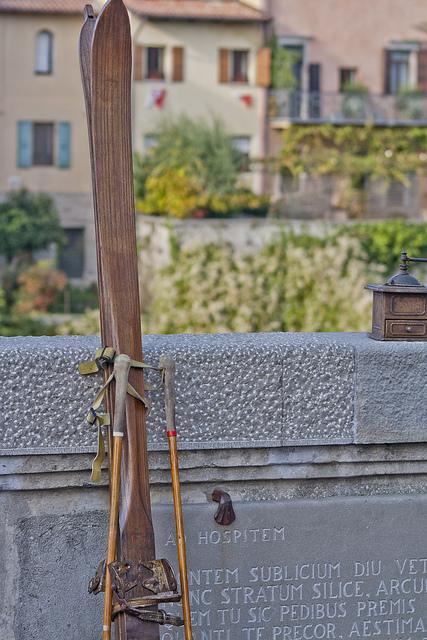What language is on the stone?
Quick response, please. Latin. Is there a balcony in the background?
Short answer required. Yes. What is that object behind the skis?
Concise answer only. Wall. Does the building in the background have shutters?
Give a very brief answer. Yes. Is there a reflection?
Short answer required. No. 